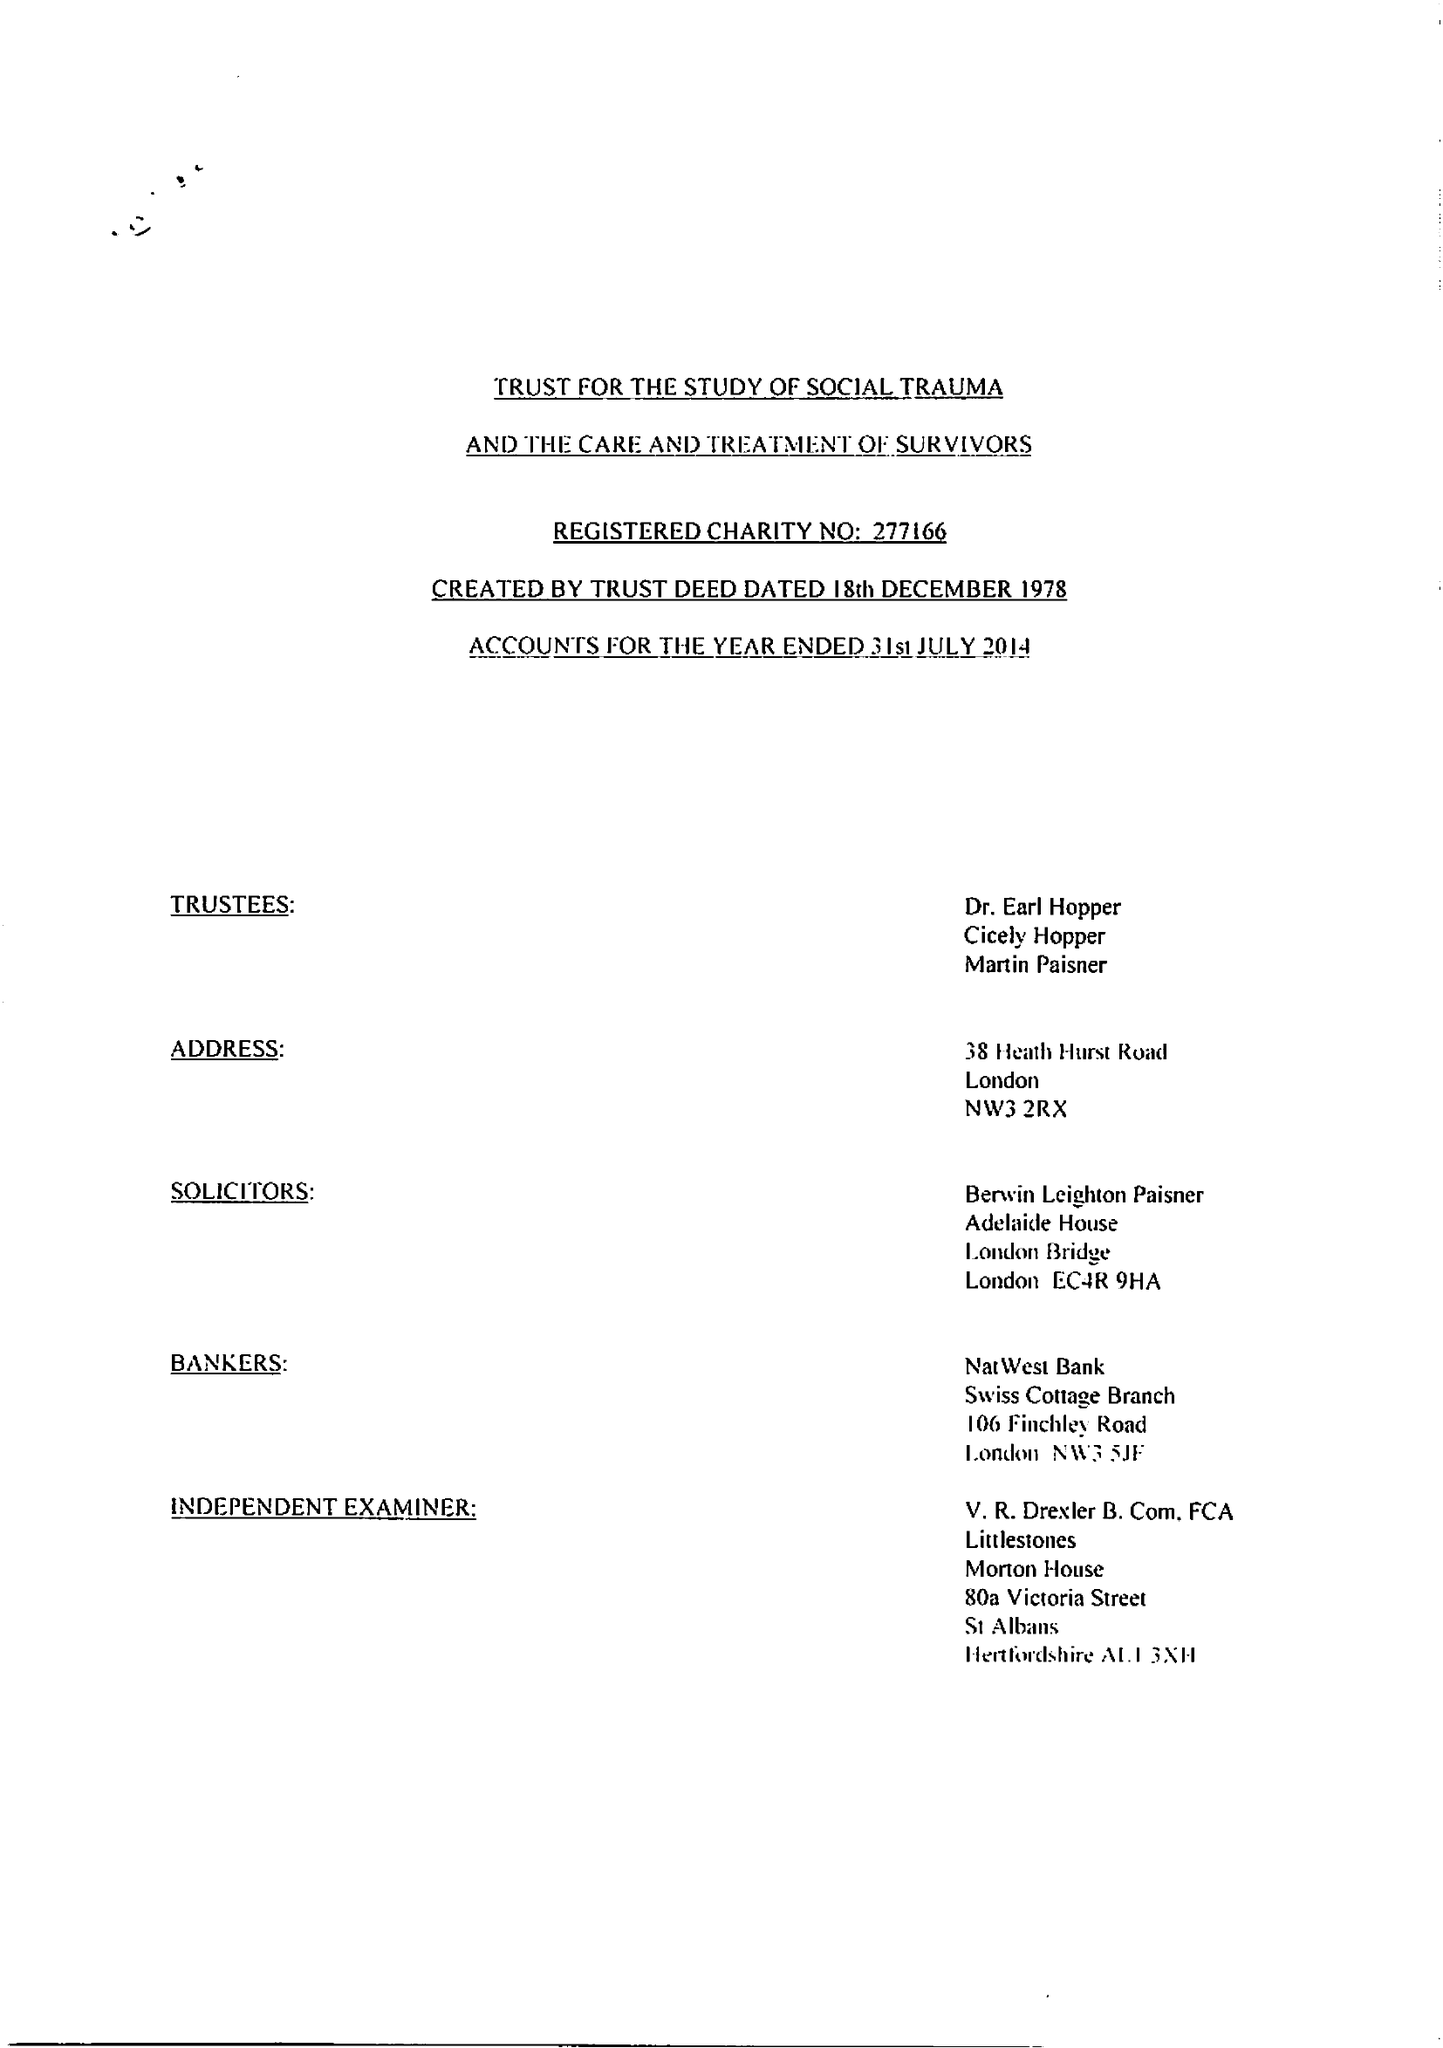What is the value for the charity_name?
Answer the question using a single word or phrase. The Trust For The Study Of Social Trauma and The Care and Treatment Of Survivors 